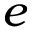Convert formula to latex. <formula><loc_0><loc_0><loc_500><loc_500>e</formula> 